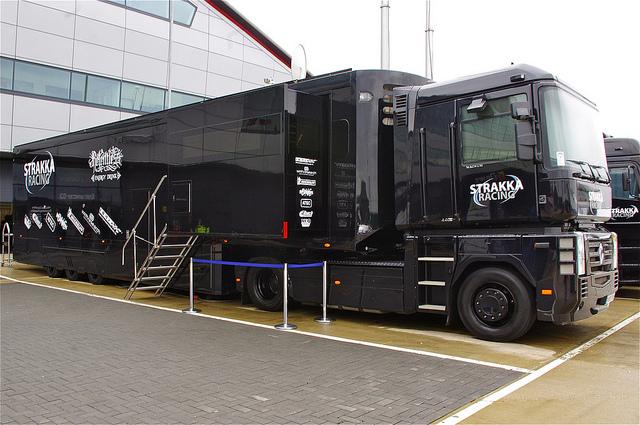What color is the truck?
Quick response, please. Black. What company's truck is this?
Answer briefly. Strakka racing. Is the truck moving?
Be succinct. No. 